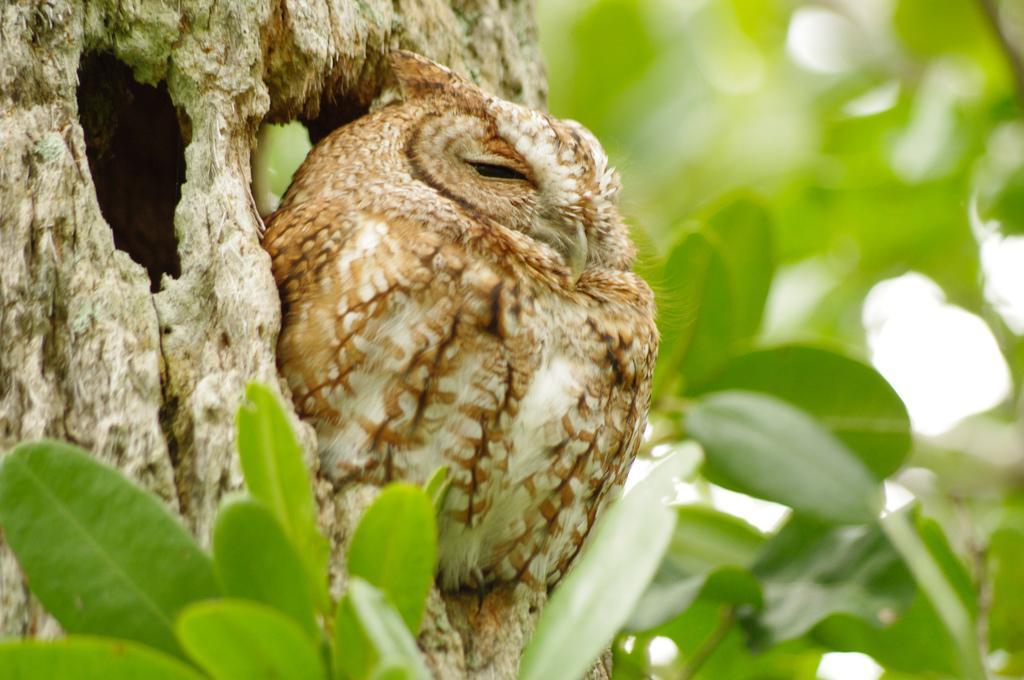Can you describe this image briefly? In the middle of the image we can see a bird and we can find few leaves. 